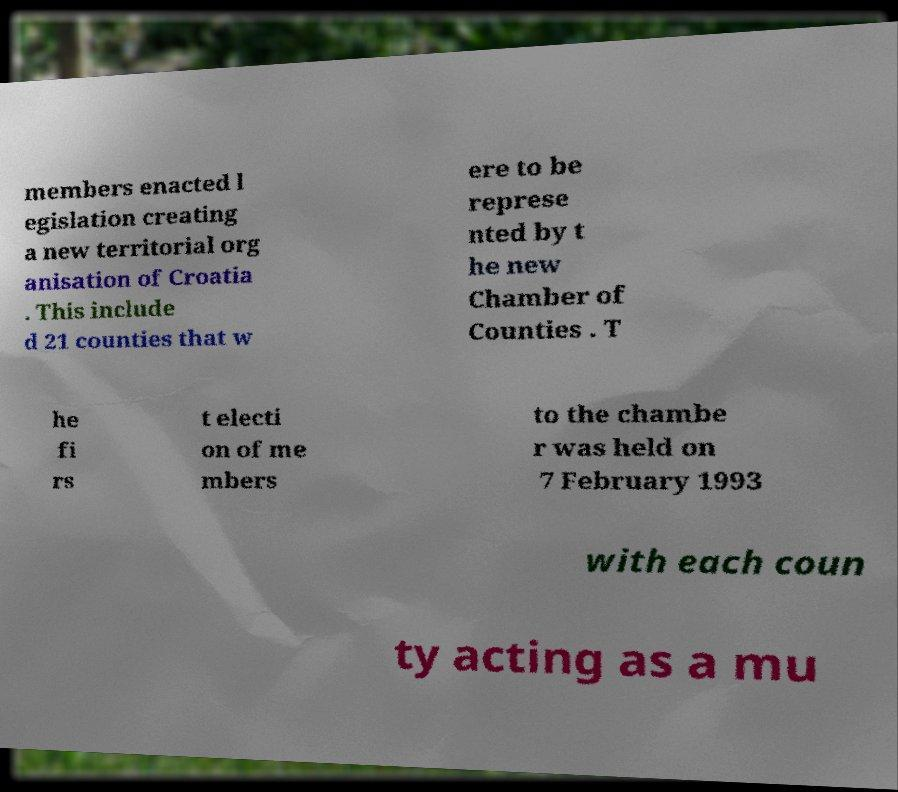Please identify and transcribe the text found in this image. members enacted l egislation creating a new territorial org anisation of Croatia . This include d 21 counties that w ere to be represe nted by t he new Chamber of Counties . T he fi rs t electi on of me mbers to the chambe r was held on 7 February 1993 with each coun ty acting as a mu 